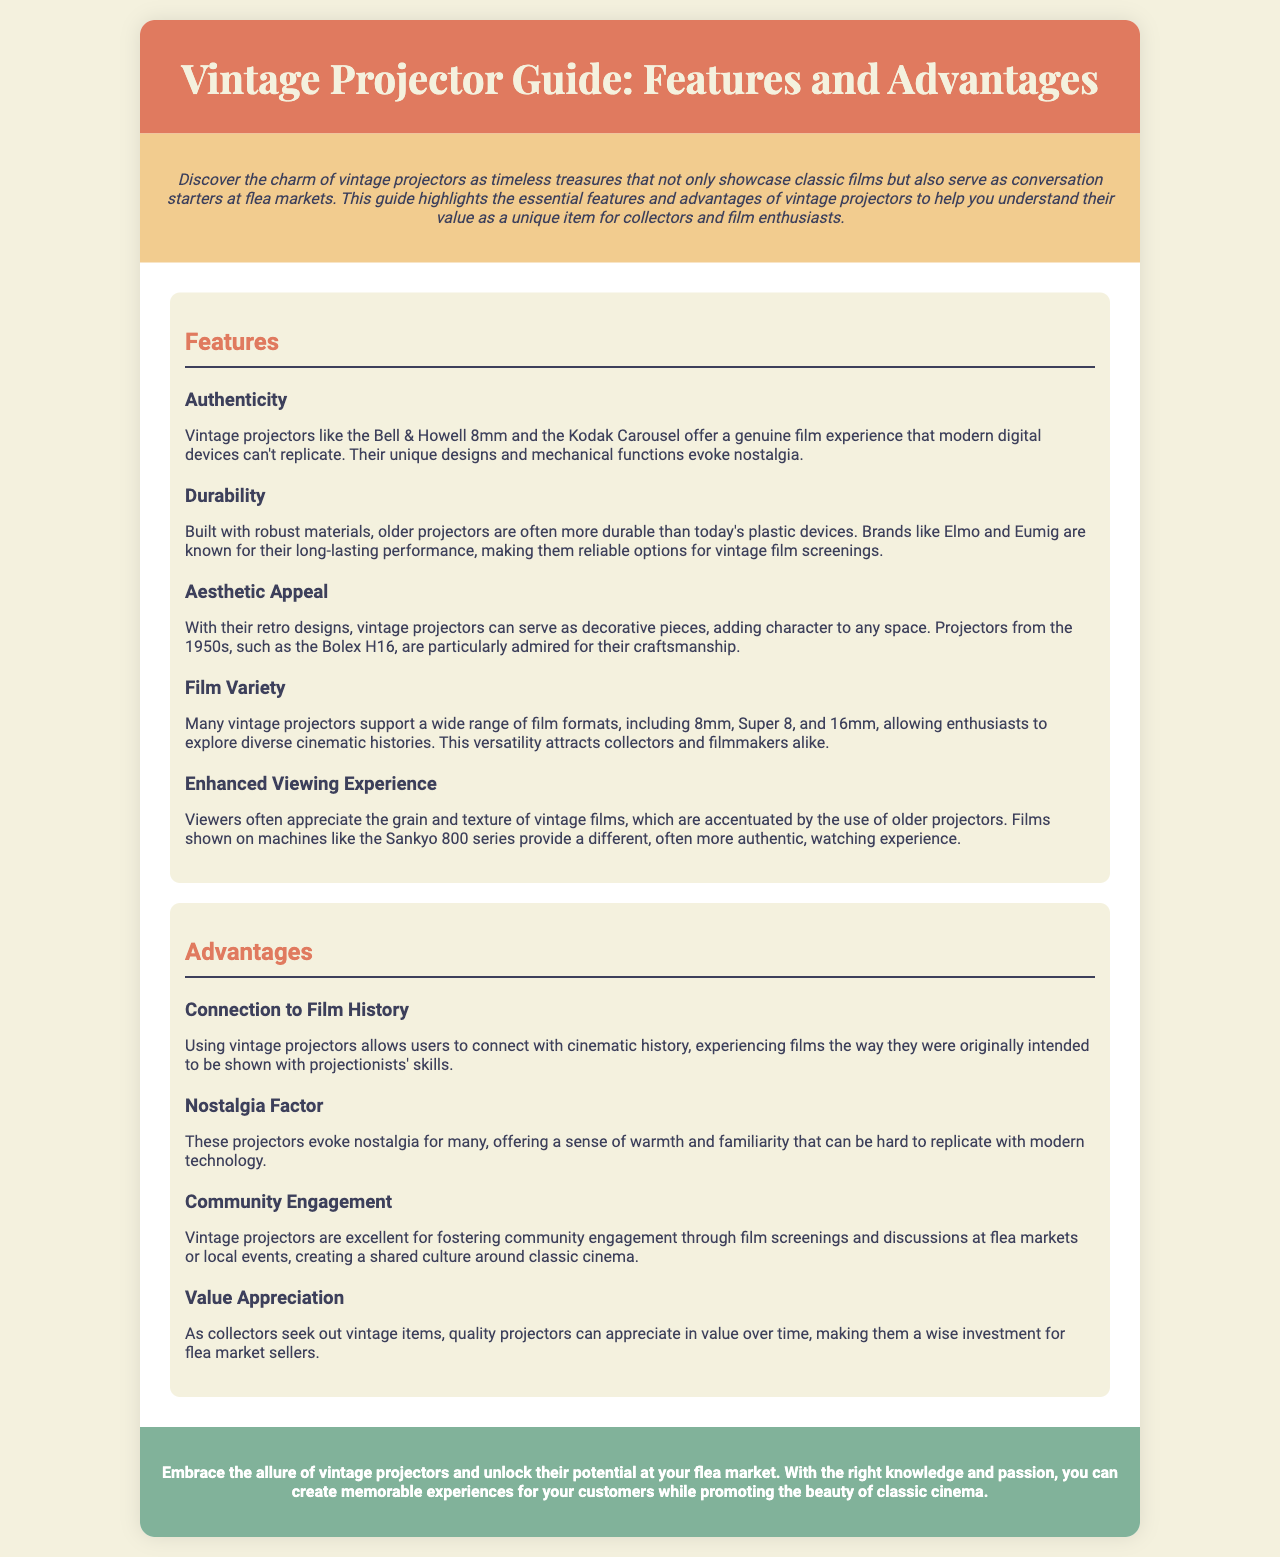What is the title of the guide? The title is stated in the header of the brochure at the top of the document.
Answer: Vintage Projector Guide: Features and Advantages Which projector brand is mentioned for authenticity? The brochure lists the Bell & Howell 8mm as a brand that offers a genuine film experience.
Answer: Bell & Howell 8mm What kind of film formats do many vintage projectors support? The document highlights that vintage projectors support various film formats, which is crucial information under the features section.
Answer: 8mm, Super 8, and 16mm What is one advantage of using vintage projectors? The advantages discussed in the brochure offer insights into why vintage projectors are valuable, with specific mentions under the advantages section.
Answer: Connection to Film History Which vintage projector is noted for aesthetic appeal? The text mentions a specific model that is admired for its craftsmanship and retro design under the features section.
Answer: Bolex H16 How many main sections are there in the brochure? By evaluating the structure of the document, I can determine how many distinct sections are presented.
Answer: Two What color is used in the conclusion section? The brochure describes the background color of the conclusion section in its description.
Answer: #81b29a What aspect of vintage projectors fosters community engagement? The reasons provided in the advantages section indicate how vintage projectors can lead to communal activities related to film.
Answer: Film screenings and discussions 